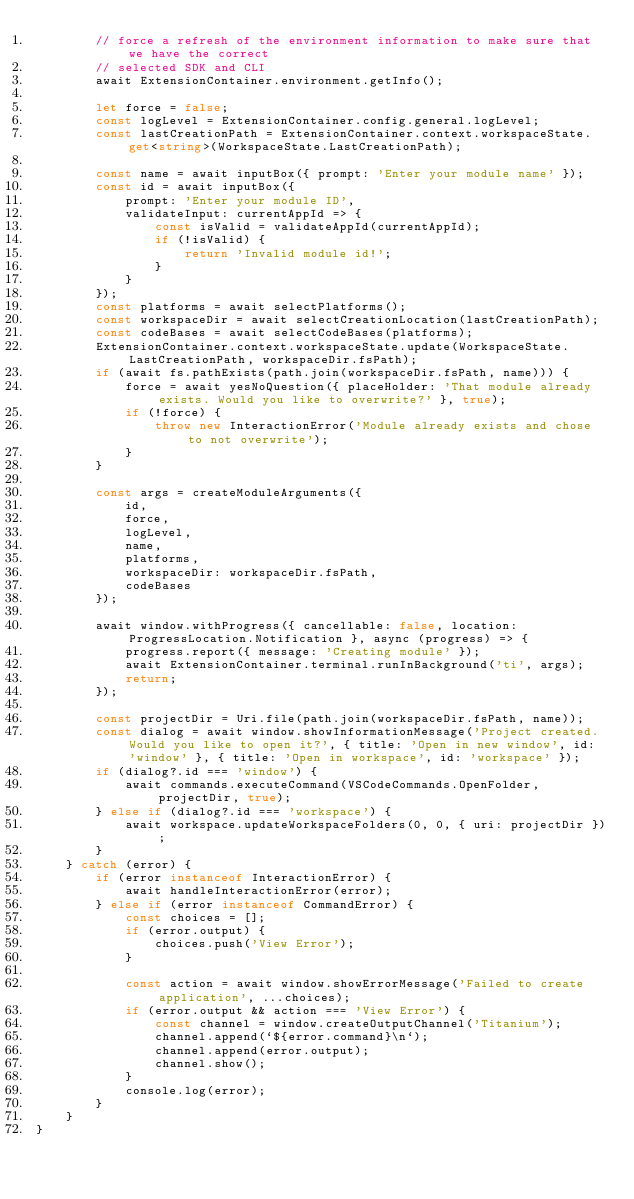<code> <loc_0><loc_0><loc_500><loc_500><_TypeScript_>		// force a refresh of the environment information to make sure that we have the correct
		// selected SDK and CLI
		await ExtensionContainer.environment.getInfo();

		let force = false;
		const logLevel = ExtensionContainer.config.general.logLevel;
		const lastCreationPath = ExtensionContainer.context.workspaceState.get<string>(WorkspaceState.LastCreationPath);

		const name = await inputBox({ prompt: 'Enter your module name' });
		const id = await inputBox({
			prompt: 'Enter your module ID',
			validateInput: currentAppId => {
				const isValid = validateAppId(currentAppId);
				if (!isValid) {
					return 'Invalid module id!';
				}
			}
		});
		const platforms = await selectPlatforms();
		const workspaceDir = await selectCreationLocation(lastCreationPath);
		const codeBases = await selectCodeBases(platforms);
		ExtensionContainer.context.workspaceState.update(WorkspaceState.LastCreationPath, workspaceDir.fsPath);
		if (await fs.pathExists(path.join(workspaceDir.fsPath, name))) {
			force = await yesNoQuestion({ placeHolder: 'That module already exists. Would you like to overwrite?' }, true);
			if (!force) {
				throw new InteractionError('Module already exists and chose to not overwrite');
			}
		}

		const args = createModuleArguments({
			id,
			force,
			logLevel,
			name,
			platforms,
			workspaceDir: workspaceDir.fsPath,
			codeBases
		});

		await window.withProgress({ cancellable: false, location: ProgressLocation.Notification }, async (progress) => {
			progress.report({ message: 'Creating module' });
			await ExtensionContainer.terminal.runInBackground('ti', args);
			return;
		});

		const projectDir = Uri.file(path.join(workspaceDir.fsPath, name));
		const dialog = await window.showInformationMessage('Project created. Would you like to open it?', { title: 'Open in new window', id: 'window' }, { title: 'Open in workspace', id: 'workspace' });
		if (dialog?.id === 'window') {
			await commands.executeCommand(VSCodeCommands.OpenFolder, projectDir, true);
		} else if (dialog?.id === 'workspace') {
			await workspace.updateWorkspaceFolders(0, 0, { uri: projectDir });
		}
	} catch (error) {
		if (error instanceof InteractionError) {
			await handleInteractionError(error);
		} else if (error instanceof CommandError) {
			const choices = [];
			if (error.output) {
				choices.push('View Error');
			}

			const action = await window.showErrorMessage('Failed to create application', ...choices);
			if (error.output && action === 'View Error') {
				const channel = window.createOutputChannel('Titanium');
				channel.append(`${error.command}\n`);
				channel.append(error.output);
				channel.show();
			}
			console.log(error);
		}
	}
}
</code> 